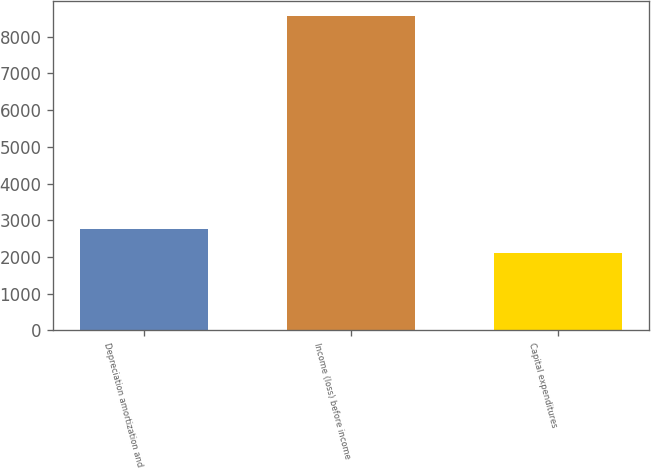<chart> <loc_0><loc_0><loc_500><loc_500><bar_chart><fcel>Depreciation amortization and<fcel>Income (loss) before income<fcel>Capital expenditures<nl><fcel>2758.8<fcel>8553<fcel>2115<nl></chart> 